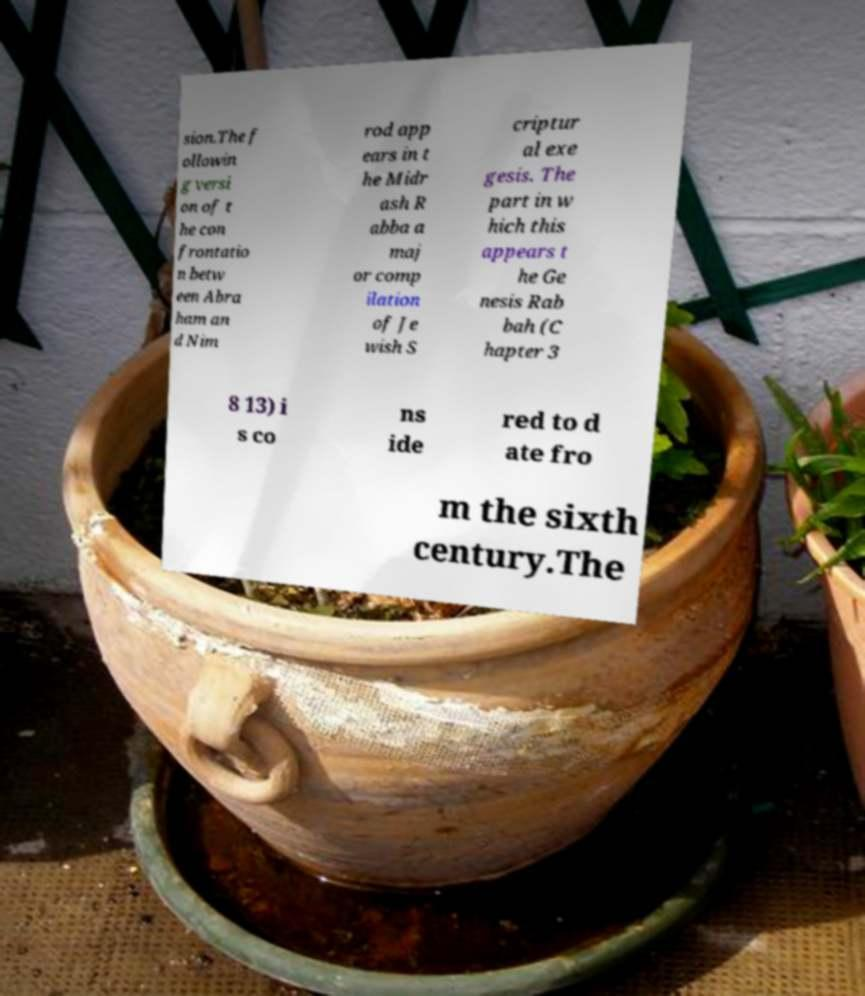Please read and relay the text visible in this image. What does it say? sion.The f ollowin g versi on of t he con frontatio n betw een Abra ham an d Nim rod app ears in t he Midr ash R abba a maj or comp ilation of Je wish S criptur al exe gesis. The part in w hich this appears t he Ge nesis Rab bah (C hapter 3 8 13) i s co ns ide red to d ate fro m the sixth century.The 